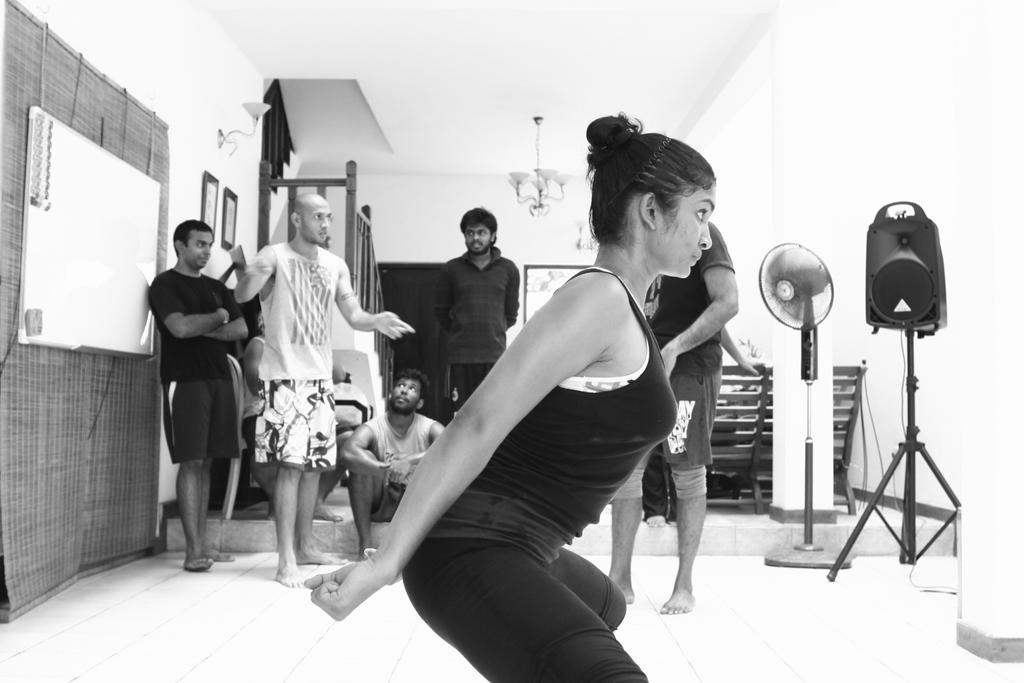What are the people in the image wearing? The people in the image are wearing clothes. What type of cooling device is present in the image? There is a table fan in the image. What part of the room can be seen in the image? The floor is visible in the image. What is used for writing or displaying information in the image? There is a whiteboard in the image. What type of decorative or functional object is present in the image? There is a frame in the image. What source of light is present in the image? There is a light in the image. What architectural feature is present in the image? There are stairs in the image. What other objects can be seen in the image besides those mentioned? There are other objects in the image. How does the person in the image blow out the candles on their birthday cake? There is no birthday cake present in the image, so it is not possible to answer that question. 